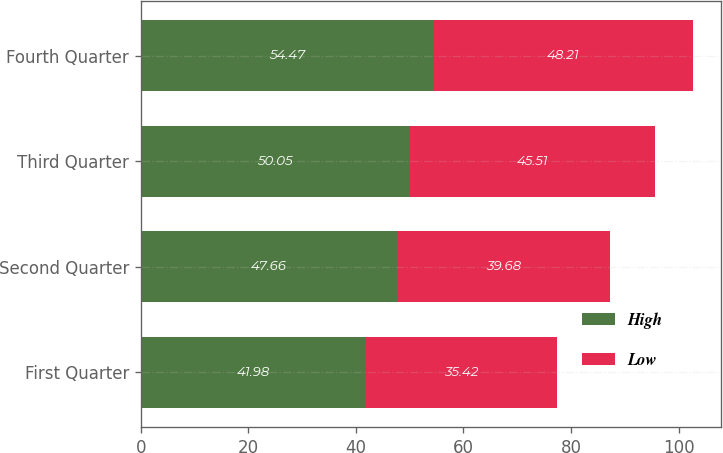<chart> <loc_0><loc_0><loc_500><loc_500><stacked_bar_chart><ecel><fcel>First Quarter<fcel>Second Quarter<fcel>Third Quarter<fcel>Fourth Quarter<nl><fcel>High<fcel>41.98<fcel>47.66<fcel>50.05<fcel>54.47<nl><fcel>Low<fcel>35.42<fcel>39.68<fcel>45.51<fcel>48.21<nl></chart> 